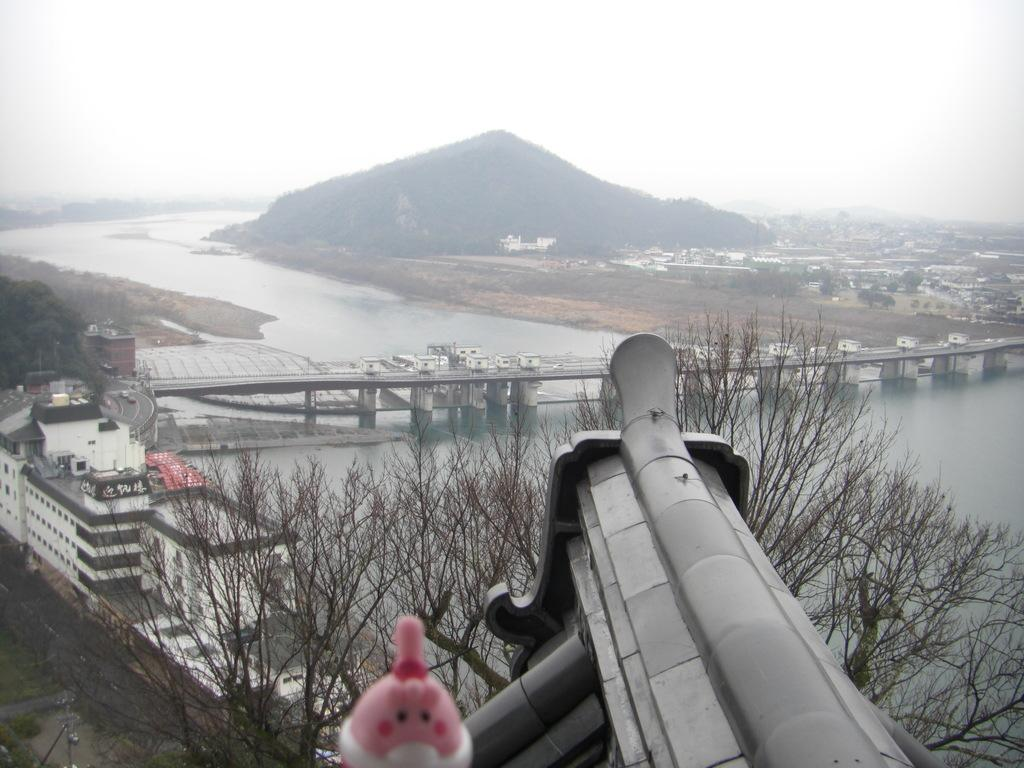What type of natural elements can be seen in the image? There are trees in the image. What type of man-made structures are present in the image? There are buildings in the image. What feature allows people or vehicles to cross the water in the image? There is a bridge over the water in the image. What type of landscape feature can be seen in the background of the image? A hill is visible in the background of the image. Where are the grapes located in the image? There are no grapes present in the image. What type of sound can be heard from the bells in the image? There are no bells present in the image. 